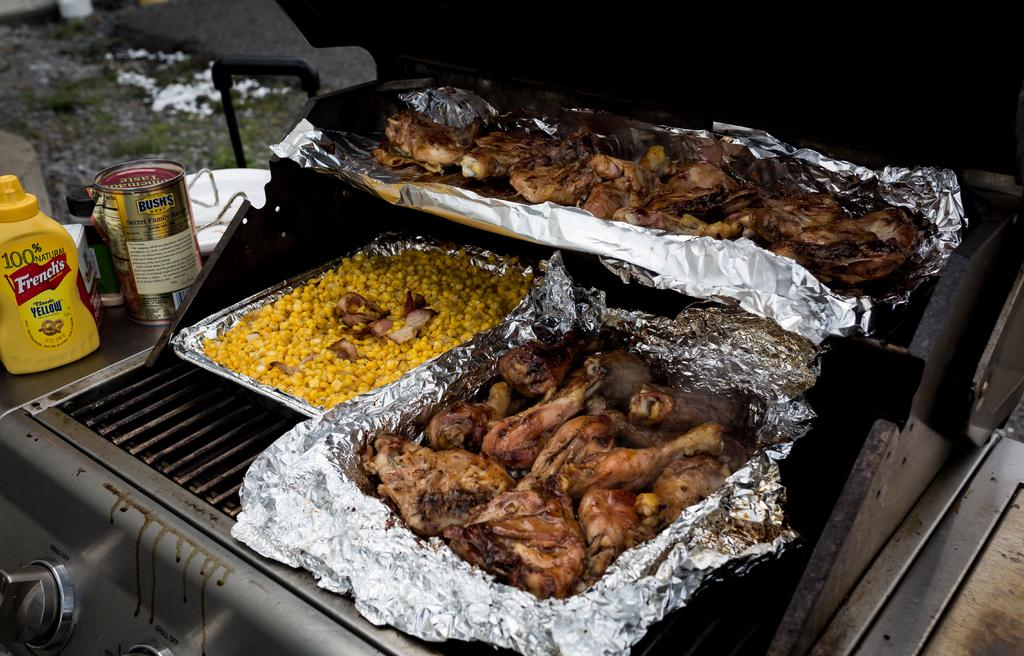<image>
Create a compact narrative representing the image presented. A lot of food on a grill next to a bottle of Frenches yellow mustard. 